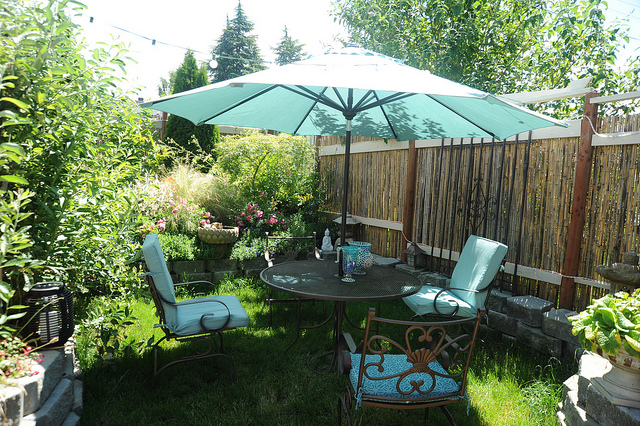<image>What kind of flowers are in this photo? It's ambiguous to know what kind of flowers are in the photo, it could be carnations, roses, daisy, or geraniums. What kind of flowers are in this photo? It is unknown what kind of flowers are in the photo. 